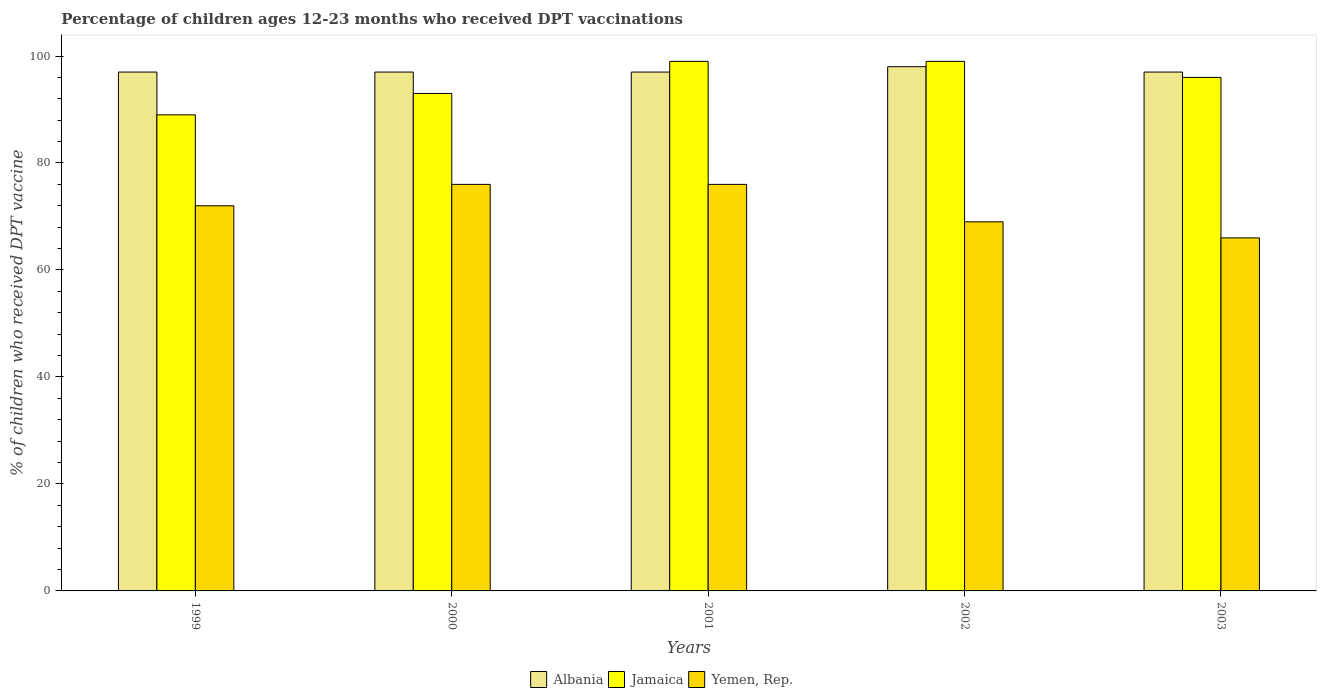How many different coloured bars are there?
Offer a terse response. 3. Are the number of bars on each tick of the X-axis equal?
Provide a succinct answer. Yes. How many bars are there on the 5th tick from the left?
Offer a very short reply. 3. What is the percentage of children who received DPT vaccination in Yemen, Rep. in 2001?
Your answer should be compact. 76. Across all years, what is the maximum percentage of children who received DPT vaccination in Yemen, Rep.?
Give a very brief answer. 76. Across all years, what is the minimum percentage of children who received DPT vaccination in Yemen, Rep.?
Your answer should be very brief. 66. In which year was the percentage of children who received DPT vaccination in Jamaica minimum?
Give a very brief answer. 1999. What is the total percentage of children who received DPT vaccination in Yemen, Rep. in the graph?
Offer a terse response. 359. What is the difference between the percentage of children who received DPT vaccination in Yemen, Rep. in 2000 and that in 2003?
Ensure brevity in your answer.  10. What is the difference between the percentage of children who received DPT vaccination in Albania in 2000 and the percentage of children who received DPT vaccination in Jamaica in 2003?
Make the answer very short. 1. What is the average percentage of children who received DPT vaccination in Albania per year?
Keep it short and to the point. 97.2. In the year 2000, what is the difference between the percentage of children who received DPT vaccination in Yemen, Rep. and percentage of children who received DPT vaccination in Albania?
Offer a very short reply. -21. What is the ratio of the percentage of children who received DPT vaccination in Jamaica in 2002 to that in 2003?
Provide a succinct answer. 1.03. What is the difference between the highest and the second highest percentage of children who received DPT vaccination in Jamaica?
Provide a short and direct response. 0. What is the difference between the highest and the lowest percentage of children who received DPT vaccination in Jamaica?
Your answer should be compact. 10. In how many years, is the percentage of children who received DPT vaccination in Albania greater than the average percentage of children who received DPT vaccination in Albania taken over all years?
Offer a terse response. 1. Is the sum of the percentage of children who received DPT vaccination in Jamaica in 2002 and 2003 greater than the maximum percentage of children who received DPT vaccination in Albania across all years?
Keep it short and to the point. Yes. What does the 2nd bar from the left in 2002 represents?
Your response must be concise. Jamaica. What does the 2nd bar from the right in 2000 represents?
Make the answer very short. Jamaica. Are all the bars in the graph horizontal?
Your answer should be very brief. No. How many years are there in the graph?
Offer a very short reply. 5. Are the values on the major ticks of Y-axis written in scientific E-notation?
Keep it short and to the point. No. Where does the legend appear in the graph?
Your answer should be compact. Bottom center. What is the title of the graph?
Your answer should be compact. Percentage of children ages 12-23 months who received DPT vaccinations. What is the label or title of the Y-axis?
Ensure brevity in your answer.  % of children who received DPT vaccine. What is the % of children who received DPT vaccine in Albania in 1999?
Provide a succinct answer. 97. What is the % of children who received DPT vaccine in Jamaica in 1999?
Your answer should be compact. 89. What is the % of children who received DPT vaccine of Albania in 2000?
Ensure brevity in your answer.  97. What is the % of children who received DPT vaccine of Jamaica in 2000?
Keep it short and to the point. 93. What is the % of children who received DPT vaccine in Albania in 2001?
Provide a succinct answer. 97. What is the % of children who received DPT vaccine of Jamaica in 2001?
Provide a short and direct response. 99. What is the % of children who received DPT vaccine of Jamaica in 2002?
Offer a terse response. 99. What is the % of children who received DPT vaccine of Albania in 2003?
Ensure brevity in your answer.  97. What is the % of children who received DPT vaccine of Jamaica in 2003?
Offer a terse response. 96. Across all years, what is the maximum % of children who received DPT vaccine in Jamaica?
Your answer should be very brief. 99. Across all years, what is the minimum % of children who received DPT vaccine in Albania?
Offer a very short reply. 97. Across all years, what is the minimum % of children who received DPT vaccine of Jamaica?
Your response must be concise. 89. Across all years, what is the minimum % of children who received DPT vaccine of Yemen, Rep.?
Offer a terse response. 66. What is the total % of children who received DPT vaccine of Albania in the graph?
Your answer should be very brief. 486. What is the total % of children who received DPT vaccine in Jamaica in the graph?
Keep it short and to the point. 476. What is the total % of children who received DPT vaccine in Yemen, Rep. in the graph?
Offer a very short reply. 359. What is the difference between the % of children who received DPT vaccine of Albania in 1999 and that in 2000?
Offer a very short reply. 0. What is the difference between the % of children who received DPT vaccine of Yemen, Rep. in 1999 and that in 2000?
Your response must be concise. -4. What is the difference between the % of children who received DPT vaccine of Jamaica in 1999 and that in 2002?
Offer a terse response. -10. What is the difference between the % of children who received DPT vaccine of Yemen, Rep. in 1999 and that in 2002?
Your answer should be compact. 3. What is the difference between the % of children who received DPT vaccine of Albania in 1999 and that in 2003?
Your answer should be very brief. 0. What is the difference between the % of children who received DPT vaccine of Jamaica in 1999 and that in 2003?
Your answer should be very brief. -7. What is the difference between the % of children who received DPT vaccine of Yemen, Rep. in 1999 and that in 2003?
Your response must be concise. 6. What is the difference between the % of children who received DPT vaccine of Albania in 2000 and that in 2001?
Make the answer very short. 0. What is the difference between the % of children who received DPT vaccine in Jamaica in 2000 and that in 2001?
Offer a terse response. -6. What is the difference between the % of children who received DPT vaccine of Yemen, Rep. in 2000 and that in 2001?
Keep it short and to the point. 0. What is the difference between the % of children who received DPT vaccine of Jamaica in 2000 and that in 2002?
Keep it short and to the point. -6. What is the difference between the % of children who received DPT vaccine of Yemen, Rep. in 2000 and that in 2002?
Make the answer very short. 7. What is the difference between the % of children who received DPT vaccine in Jamaica in 2000 and that in 2003?
Your answer should be compact. -3. What is the difference between the % of children who received DPT vaccine of Yemen, Rep. in 2000 and that in 2003?
Give a very brief answer. 10. What is the difference between the % of children who received DPT vaccine in Yemen, Rep. in 2001 and that in 2002?
Give a very brief answer. 7. What is the difference between the % of children who received DPT vaccine of Albania in 2002 and that in 2003?
Your response must be concise. 1. What is the difference between the % of children who received DPT vaccine in Jamaica in 2002 and that in 2003?
Offer a very short reply. 3. What is the difference between the % of children who received DPT vaccine in Yemen, Rep. in 2002 and that in 2003?
Your answer should be very brief. 3. What is the difference between the % of children who received DPT vaccine of Albania in 1999 and the % of children who received DPT vaccine of Jamaica in 2000?
Offer a very short reply. 4. What is the difference between the % of children who received DPT vaccine of Albania in 1999 and the % of children who received DPT vaccine of Yemen, Rep. in 2000?
Provide a succinct answer. 21. What is the difference between the % of children who received DPT vaccine in Albania in 1999 and the % of children who received DPT vaccine in Jamaica in 2001?
Provide a succinct answer. -2. What is the difference between the % of children who received DPT vaccine of Jamaica in 1999 and the % of children who received DPT vaccine of Yemen, Rep. in 2002?
Provide a short and direct response. 20. What is the difference between the % of children who received DPT vaccine of Jamaica in 1999 and the % of children who received DPT vaccine of Yemen, Rep. in 2003?
Ensure brevity in your answer.  23. What is the difference between the % of children who received DPT vaccine in Albania in 2000 and the % of children who received DPT vaccine in Jamaica in 2001?
Offer a very short reply. -2. What is the difference between the % of children who received DPT vaccine in Albania in 2000 and the % of children who received DPT vaccine in Jamaica in 2002?
Your answer should be compact. -2. What is the difference between the % of children who received DPT vaccine of Jamaica in 2000 and the % of children who received DPT vaccine of Yemen, Rep. in 2002?
Your answer should be very brief. 24. What is the difference between the % of children who received DPT vaccine of Albania in 2000 and the % of children who received DPT vaccine of Jamaica in 2003?
Your answer should be very brief. 1. What is the difference between the % of children who received DPT vaccine in Albania in 2000 and the % of children who received DPT vaccine in Yemen, Rep. in 2003?
Offer a very short reply. 31. What is the difference between the % of children who received DPT vaccine of Jamaica in 2000 and the % of children who received DPT vaccine of Yemen, Rep. in 2003?
Keep it short and to the point. 27. What is the difference between the % of children who received DPT vaccine of Albania in 2001 and the % of children who received DPT vaccine of Yemen, Rep. in 2002?
Your answer should be very brief. 28. What is the difference between the % of children who received DPT vaccine of Albania in 2002 and the % of children who received DPT vaccine of Jamaica in 2003?
Your answer should be compact. 2. What is the difference between the % of children who received DPT vaccine in Albania in 2002 and the % of children who received DPT vaccine in Yemen, Rep. in 2003?
Provide a succinct answer. 32. What is the difference between the % of children who received DPT vaccine in Jamaica in 2002 and the % of children who received DPT vaccine in Yemen, Rep. in 2003?
Give a very brief answer. 33. What is the average % of children who received DPT vaccine of Albania per year?
Ensure brevity in your answer.  97.2. What is the average % of children who received DPT vaccine of Jamaica per year?
Ensure brevity in your answer.  95.2. What is the average % of children who received DPT vaccine of Yemen, Rep. per year?
Your answer should be compact. 71.8. In the year 1999, what is the difference between the % of children who received DPT vaccine of Albania and % of children who received DPT vaccine of Yemen, Rep.?
Your response must be concise. 25. In the year 1999, what is the difference between the % of children who received DPT vaccine of Jamaica and % of children who received DPT vaccine of Yemen, Rep.?
Provide a succinct answer. 17. In the year 2000, what is the difference between the % of children who received DPT vaccine of Albania and % of children who received DPT vaccine of Jamaica?
Your answer should be very brief. 4. In the year 2001, what is the difference between the % of children who received DPT vaccine in Albania and % of children who received DPT vaccine in Jamaica?
Ensure brevity in your answer.  -2. In the year 2001, what is the difference between the % of children who received DPT vaccine of Albania and % of children who received DPT vaccine of Yemen, Rep.?
Offer a terse response. 21. In the year 2002, what is the difference between the % of children who received DPT vaccine in Albania and % of children who received DPT vaccine in Yemen, Rep.?
Keep it short and to the point. 29. In the year 2002, what is the difference between the % of children who received DPT vaccine in Jamaica and % of children who received DPT vaccine in Yemen, Rep.?
Your response must be concise. 30. In the year 2003, what is the difference between the % of children who received DPT vaccine in Albania and % of children who received DPT vaccine in Jamaica?
Your answer should be compact. 1. In the year 2003, what is the difference between the % of children who received DPT vaccine of Albania and % of children who received DPT vaccine of Yemen, Rep.?
Ensure brevity in your answer.  31. What is the ratio of the % of children who received DPT vaccine in Jamaica in 1999 to that in 2000?
Your response must be concise. 0.96. What is the ratio of the % of children who received DPT vaccine of Yemen, Rep. in 1999 to that in 2000?
Provide a succinct answer. 0.95. What is the ratio of the % of children who received DPT vaccine of Jamaica in 1999 to that in 2001?
Make the answer very short. 0.9. What is the ratio of the % of children who received DPT vaccine in Albania in 1999 to that in 2002?
Your answer should be very brief. 0.99. What is the ratio of the % of children who received DPT vaccine of Jamaica in 1999 to that in 2002?
Provide a short and direct response. 0.9. What is the ratio of the % of children who received DPT vaccine of Yemen, Rep. in 1999 to that in 2002?
Your response must be concise. 1.04. What is the ratio of the % of children who received DPT vaccine in Albania in 1999 to that in 2003?
Offer a terse response. 1. What is the ratio of the % of children who received DPT vaccine of Jamaica in 1999 to that in 2003?
Provide a short and direct response. 0.93. What is the ratio of the % of children who received DPT vaccine in Yemen, Rep. in 1999 to that in 2003?
Offer a very short reply. 1.09. What is the ratio of the % of children who received DPT vaccine in Jamaica in 2000 to that in 2001?
Give a very brief answer. 0.94. What is the ratio of the % of children who received DPT vaccine in Yemen, Rep. in 2000 to that in 2001?
Keep it short and to the point. 1. What is the ratio of the % of children who received DPT vaccine of Jamaica in 2000 to that in 2002?
Your answer should be very brief. 0.94. What is the ratio of the % of children who received DPT vaccine of Yemen, Rep. in 2000 to that in 2002?
Your response must be concise. 1.1. What is the ratio of the % of children who received DPT vaccine of Jamaica in 2000 to that in 2003?
Give a very brief answer. 0.97. What is the ratio of the % of children who received DPT vaccine in Yemen, Rep. in 2000 to that in 2003?
Make the answer very short. 1.15. What is the ratio of the % of children who received DPT vaccine of Yemen, Rep. in 2001 to that in 2002?
Keep it short and to the point. 1.1. What is the ratio of the % of children who received DPT vaccine in Jamaica in 2001 to that in 2003?
Ensure brevity in your answer.  1.03. What is the ratio of the % of children who received DPT vaccine of Yemen, Rep. in 2001 to that in 2003?
Provide a short and direct response. 1.15. What is the ratio of the % of children who received DPT vaccine in Albania in 2002 to that in 2003?
Keep it short and to the point. 1.01. What is the ratio of the % of children who received DPT vaccine in Jamaica in 2002 to that in 2003?
Your response must be concise. 1.03. What is the ratio of the % of children who received DPT vaccine in Yemen, Rep. in 2002 to that in 2003?
Your response must be concise. 1.05. What is the difference between the highest and the lowest % of children who received DPT vaccine in Albania?
Your answer should be compact. 1. What is the difference between the highest and the lowest % of children who received DPT vaccine of Yemen, Rep.?
Your answer should be compact. 10. 